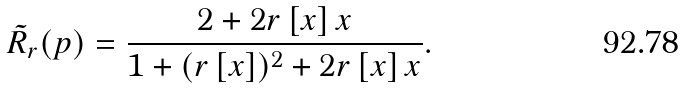Convert formula to latex. <formula><loc_0><loc_0><loc_500><loc_500>\tilde { R } _ { r } ( p ) = \frac { 2 + 2 r \left [ x \right ] x } { 1 + ( r \left [ x \right ] ) ^ { 2 } + 2 r \left [ x \right ] x } .</formula> 